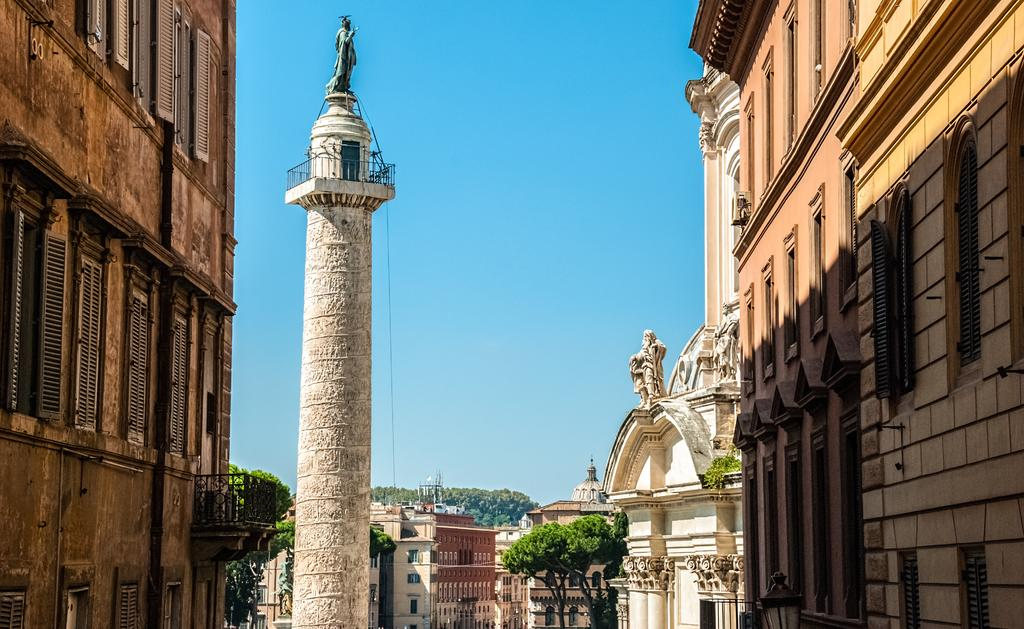What can be seen in the foreground of the image? There are buildings and a sculpture on a pillar in the foreground of the image. What is the background of the image composed of? There are trees, buildings, and the sky visible in the background of the image. What type of yam is being served in the room in the image? There is no room or yam present in the image; it features buildings, a sculpture, trees, and the sky. What flavor of soda is being consumed by the people in the image? There are no people or soda present in the image. 